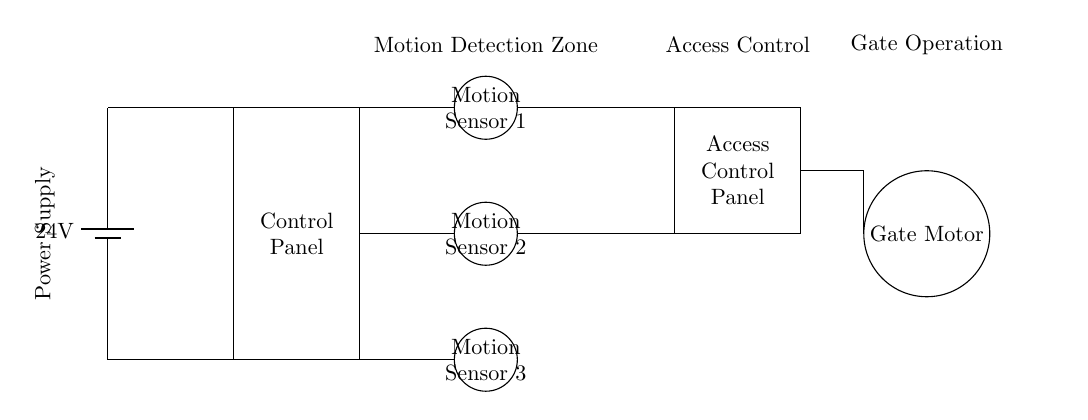What is the voltage of the power supply in this circuit? The voltage of the power supply is specified as 24 volts. This is indicated in the diagram where the battery symbol is marked with "24V".
Answer: 24 volts How many motion sensors are present in this circuit? There are three motion sensors shown in the circuit diagram. They are labeled as Motion Sensor 1, 2, and 3, and are located in a vertical alignment on the left side of the circuit.
Answer: Three What component controls the access to the gate? The component responsible for controlling access to the gate is the Access Control Panel. It is positioned to the right of the motion sensors and is specifically labeled in the diagram.
Answer: Access Control Panel What is the primary function of the gate motor in this circuit? The primary function of the gate motor is to operate or move the gate based on the signals it receives from the Access Control Panel. It is connected directly to the access control and shows its role in gate operation.
Answer: Operate the gate How does the power supply connect to the circuit? The power supply connects directly to the control panel indicated by lines leading from the battery to the control panel. This establishes that the control panel receives power from the battery to function properly.
Answer: Directly to the control panel 